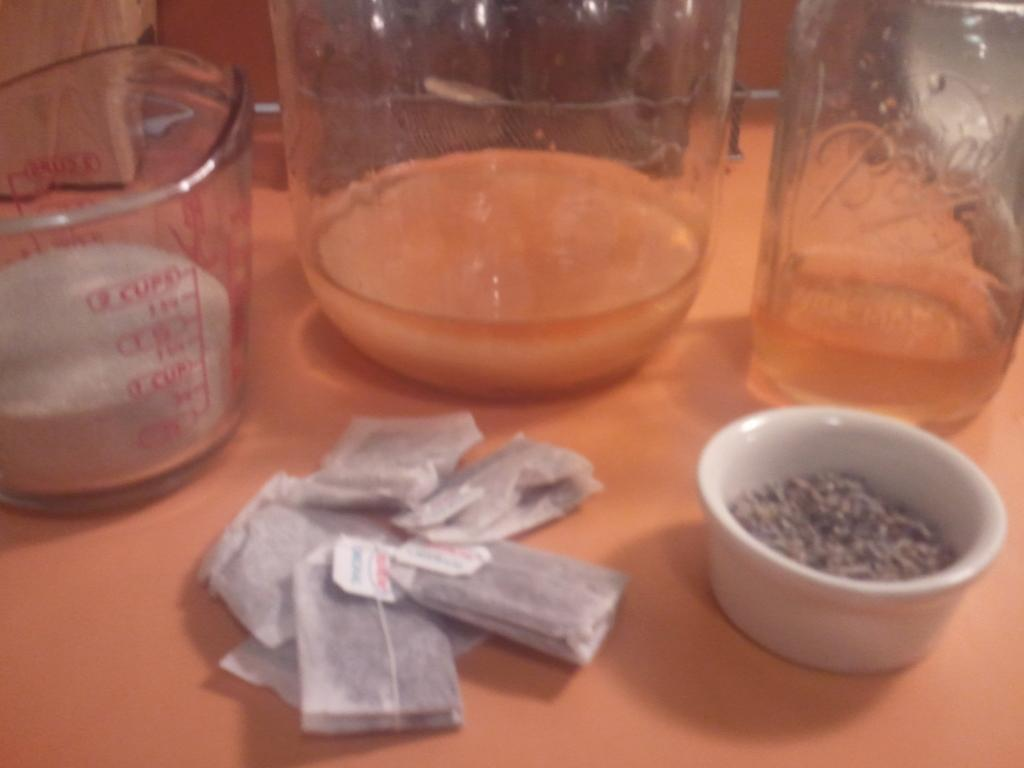<image>
Render a clear and concise summary of the photo. Glass beakers on a table with one holding something at 0 cups. 